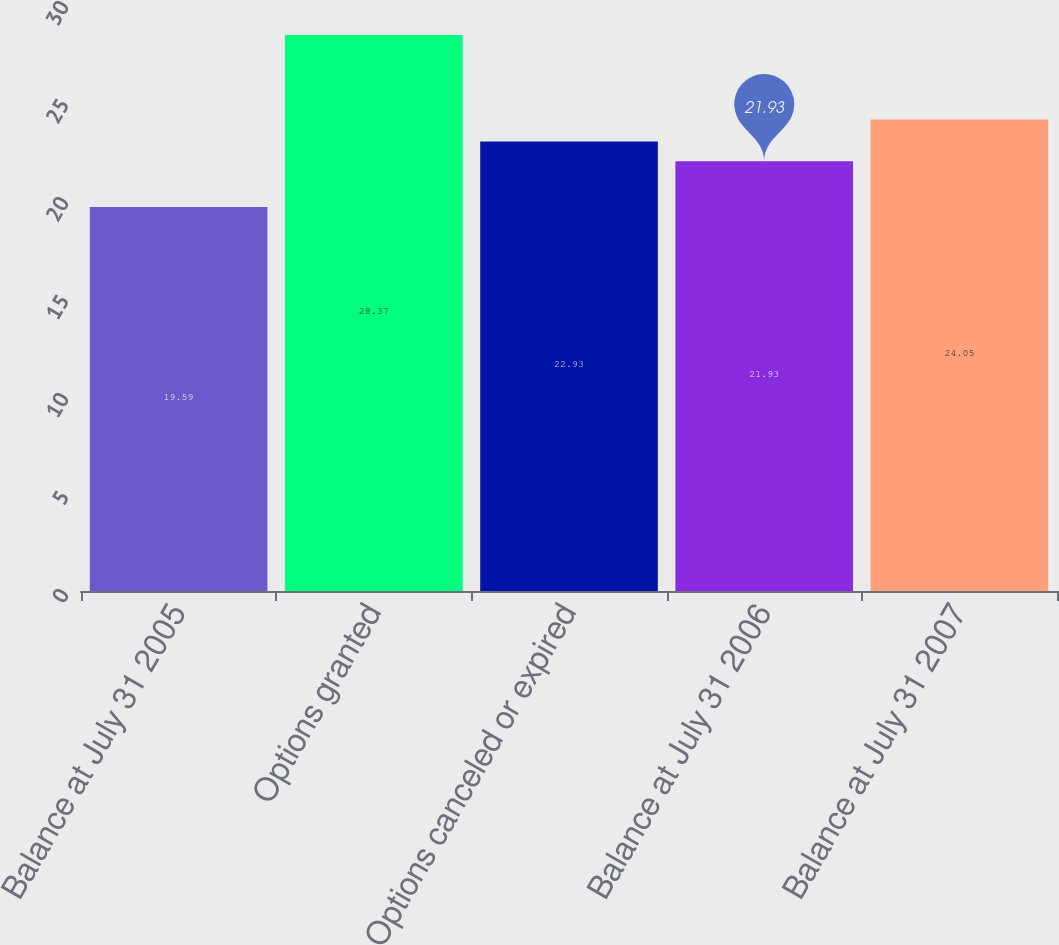Convert chart to OTSL. <chart><loc_0><loc_0><loc_500><loc_500><bar_chart><fcel>Balance at July 31 2005<fcel>Options granted<fcel>Options canceled or expired<fcel>Balance at July 31 2006<fcel>Balance at July 31 2007<nl><fcel>19.59<fcel>28.37<fcel>22.93<fcel>21.93<fcel>24.05<nl></chart> 